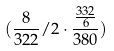<formula> <loc_0><loc_0><loc_500><loc_500>( \frac { 8 } { 3 2 2 } / 2 \cdot \frac { \frac { 3 3 2 } { 6 } } { 3 8 0 } )</formula> 